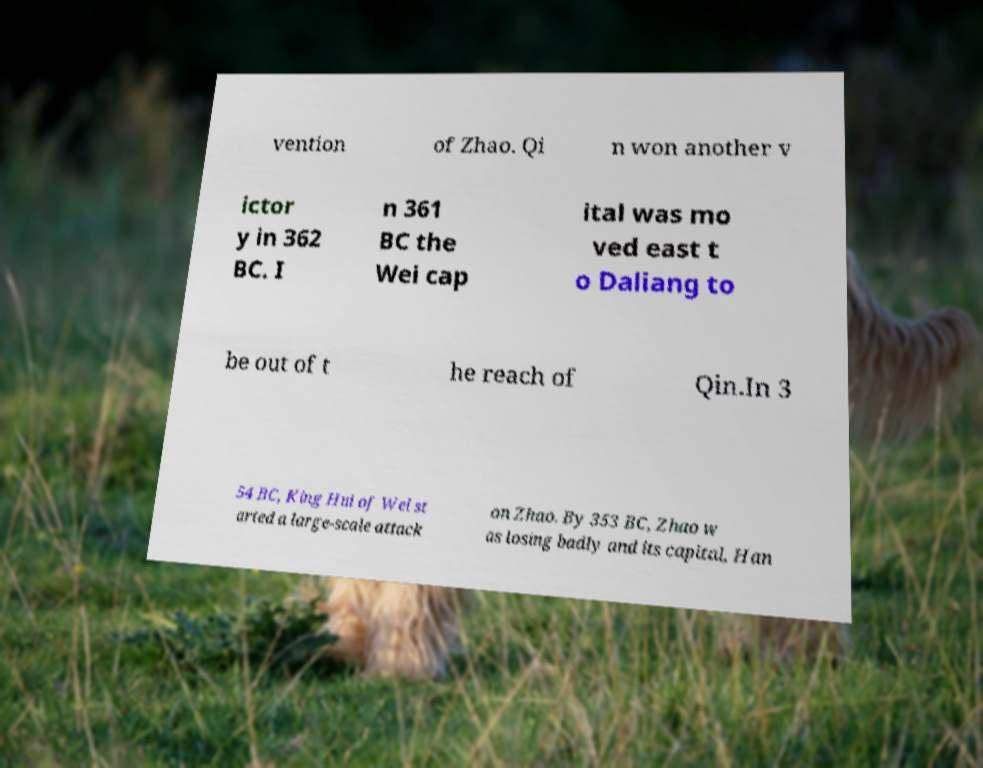Could you extract and type out the text from this image? vention of Zhao. Qi n won another v ictor y in 362 BC. I n 361 BC the Wei cap ital was mo ved east t o Daliang to be out of t he reach of Qin.In 3 54 BC, King Hui of Wei st arted a large-scale attack on Zhao. By 353 BC, Zhao w as losing badly and its capital, Han 